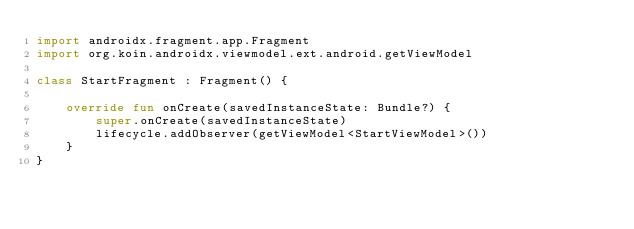<code> <loc_0><loc_0><loc_500><loc_500><_Kotlin_>import androidx.fragment.app.Fragment
import org.koin.androidx.viewmodel.ext.android.getViewModel

class StartFragment : Fragment() {

    override fun onCreate(savedInstanceState: Bundle?) {
        super.onCreate(savedInstanceState)
        lifecycle.addObserver(getViewModel<StartViewModel>())
    }
}
</code> 